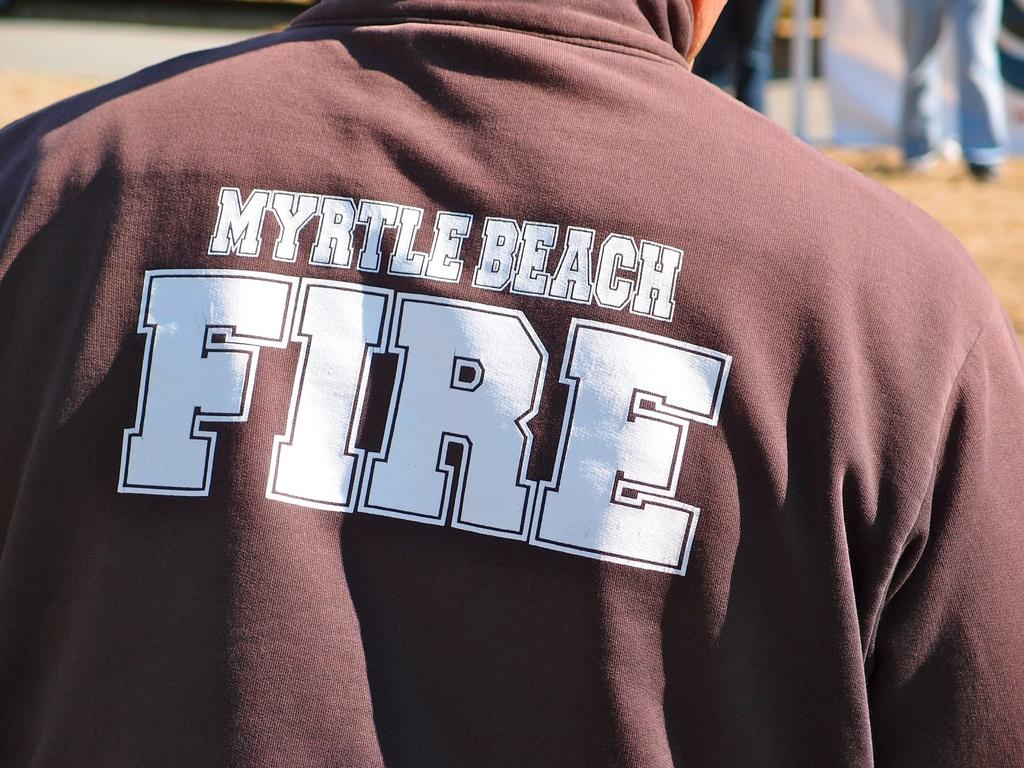<image>
Share a concise interpretation of the image provided. A man wears a Myrtle Beach Fire shirt. 